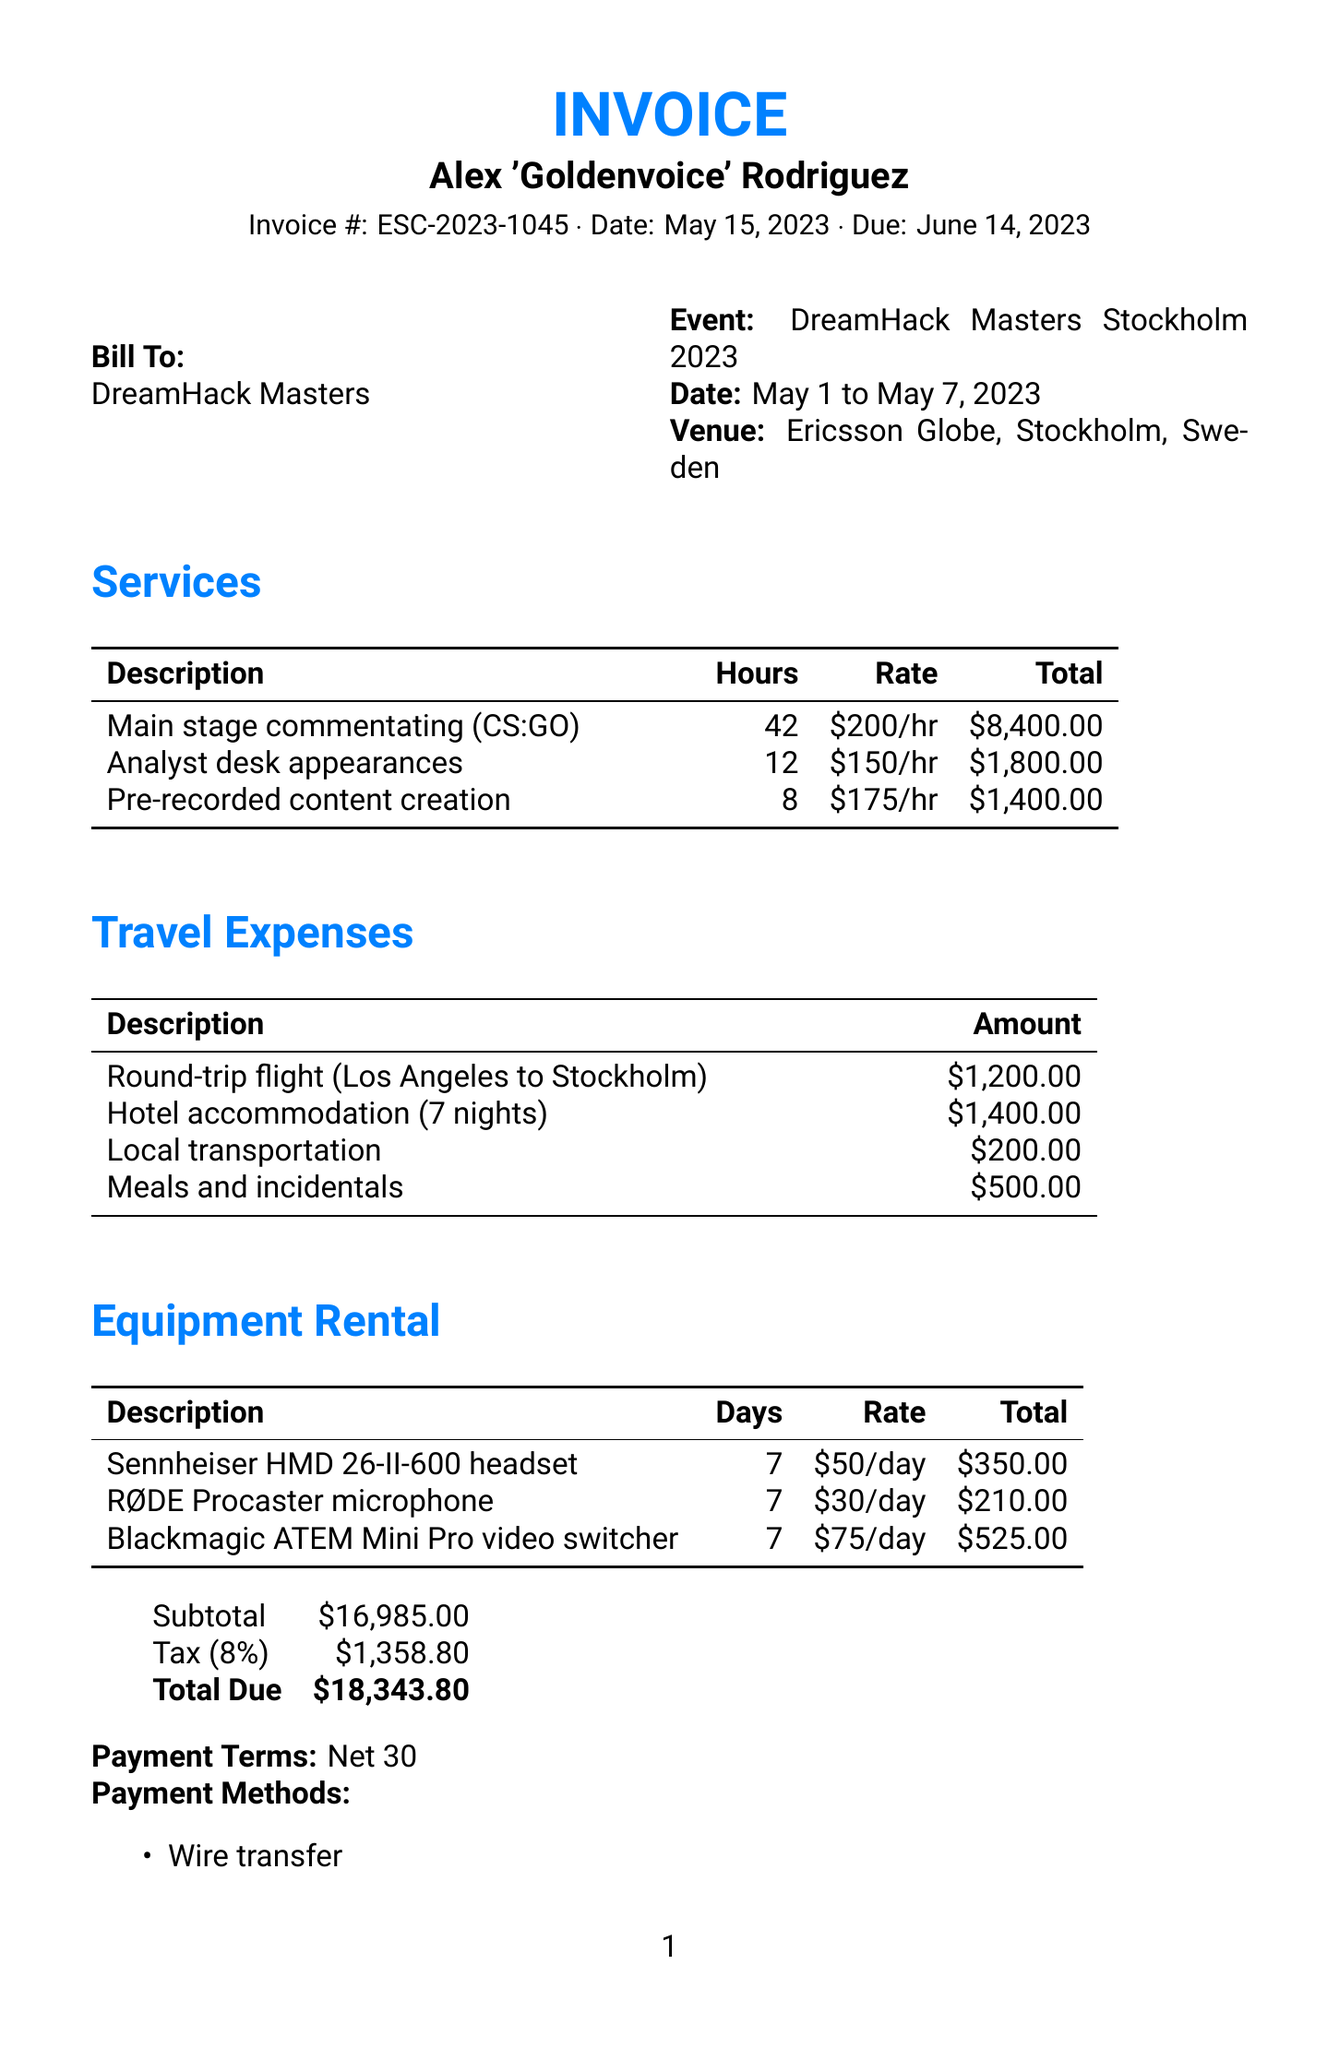what is the invoice number? The invoice number is listed at the top of the document in the invoice header section.
Answer: ESC-2023-1045 who is the commentator? The commentator's name is mentioned in the invoice header section.
Answer: Alex 'Goldenvoice' Rodriguez what is the subtotal amount? The subtotal is detailed in the financial summary section of the document.
Answer: $16,985.00 how many hours were dedicated to main stage commentating? The hours for main stage commentating are specified in the services section of the document.
Answer: 42 what was the total amount for equipment rental? The total for equipment rental is included in the financial summary.
Answer: $1,085.00 what is the due date for payment? The due date is listed in the invoice header section.
Answer: June 14, 2023 how much is the tax amount? The tax amount is presented in the financial summary section of the document.
Answer: $1,358.80 what is the payment term specified? The payment term is mentioned in the document, outlining when payment is expected.
Answer: Net 30 who should payments be made to? The payment methods section clarifies the recipient's email for payments.
Answer: alex.rodriguez@esportsvoice.com 